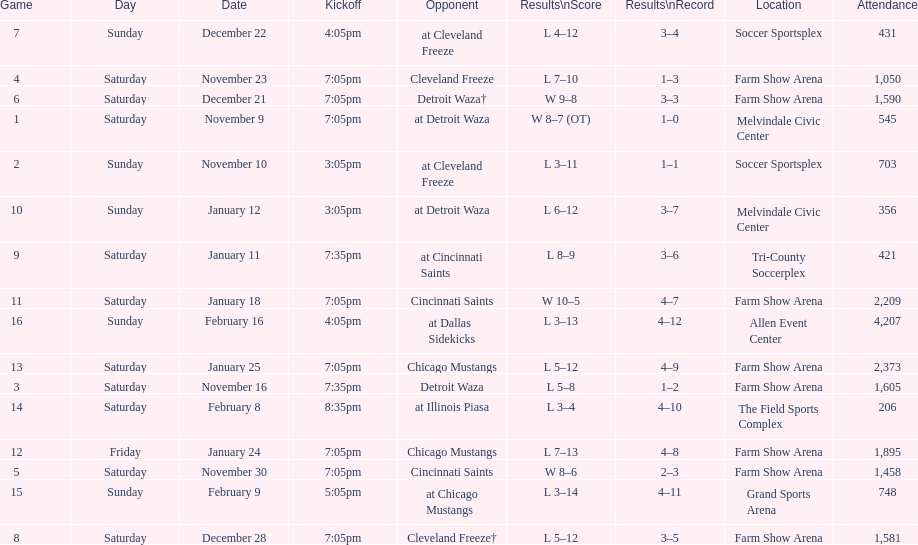How long was the teams longest losing streak? 5 games. 